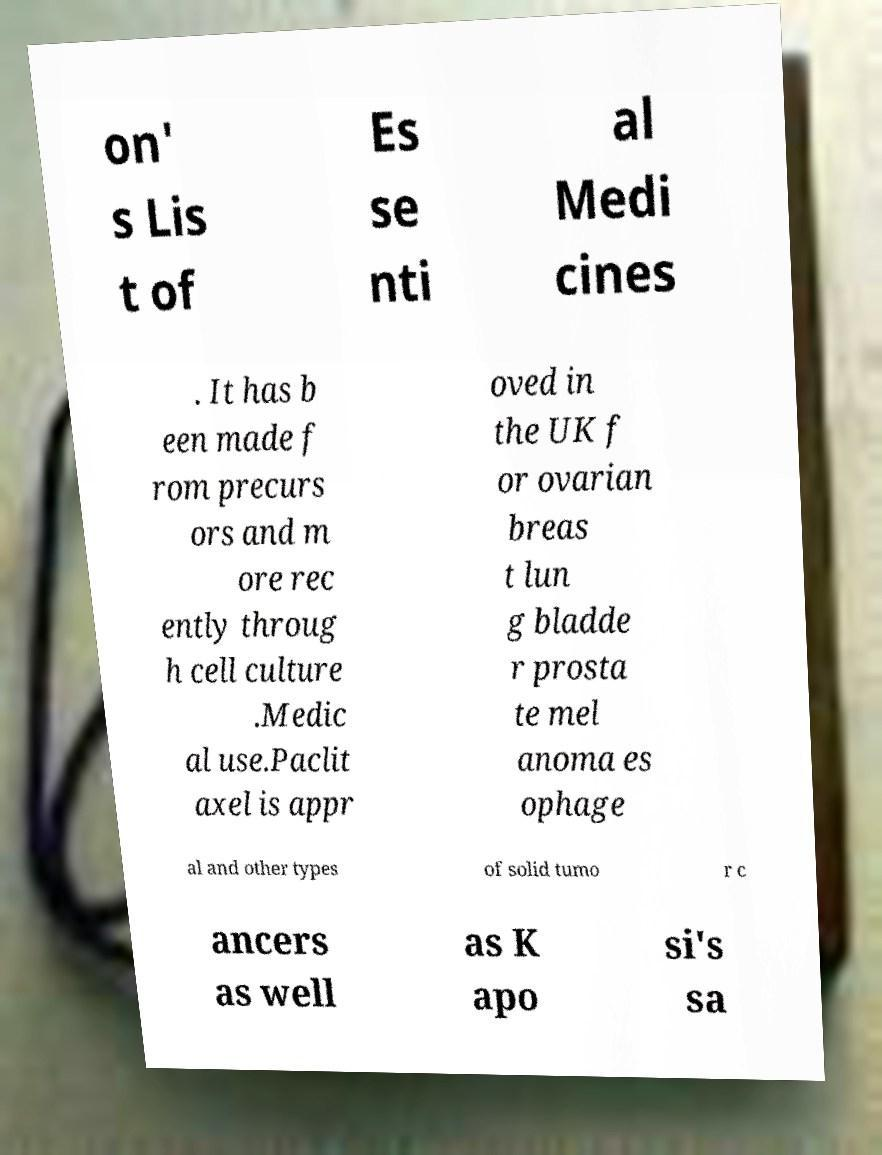Please identify and transcribe the text found in this image. on' s Lis t of Es se nti al Medi cines . It has b een made f rom precurs ors and m ore rec ently throug h cell culture .Medic al use.Paclit axel is appr oved in the UK f or ovarian breas t lun g bladde r prosta te mel anoma es ophage al and other types of solid tumo r c ancers as well as K apo si's sa 